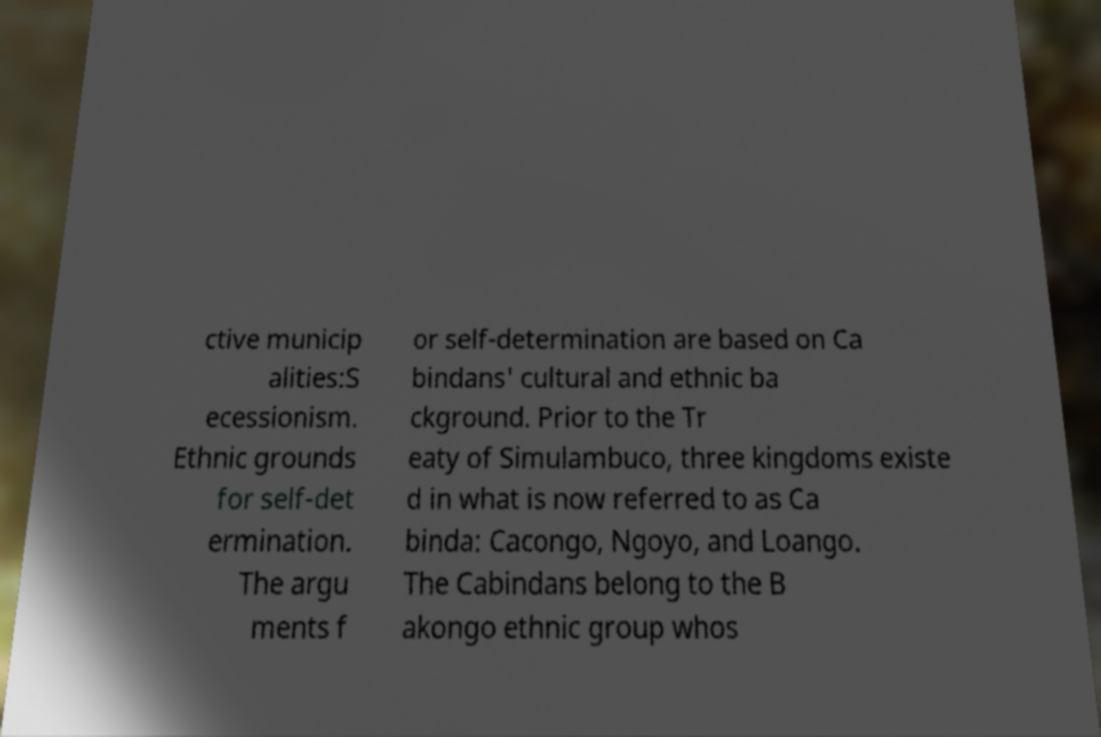For documentation purposes, I need the text within this image transcribed. Could you provide that? ctive municip alities:S ecessionism. Ethnic grounds for self-det ermination. The argu ments f or self-determination are based on Ca bindans' cultural and ethnic ba ckground. Prior to the Tr eaty of Simulambuco, three kingdoms existe d in what is now referred to as Ca binda: Cacongo, Ngoyo, and Loango. The Cabindans belong to the B akongo ethnic group whos 